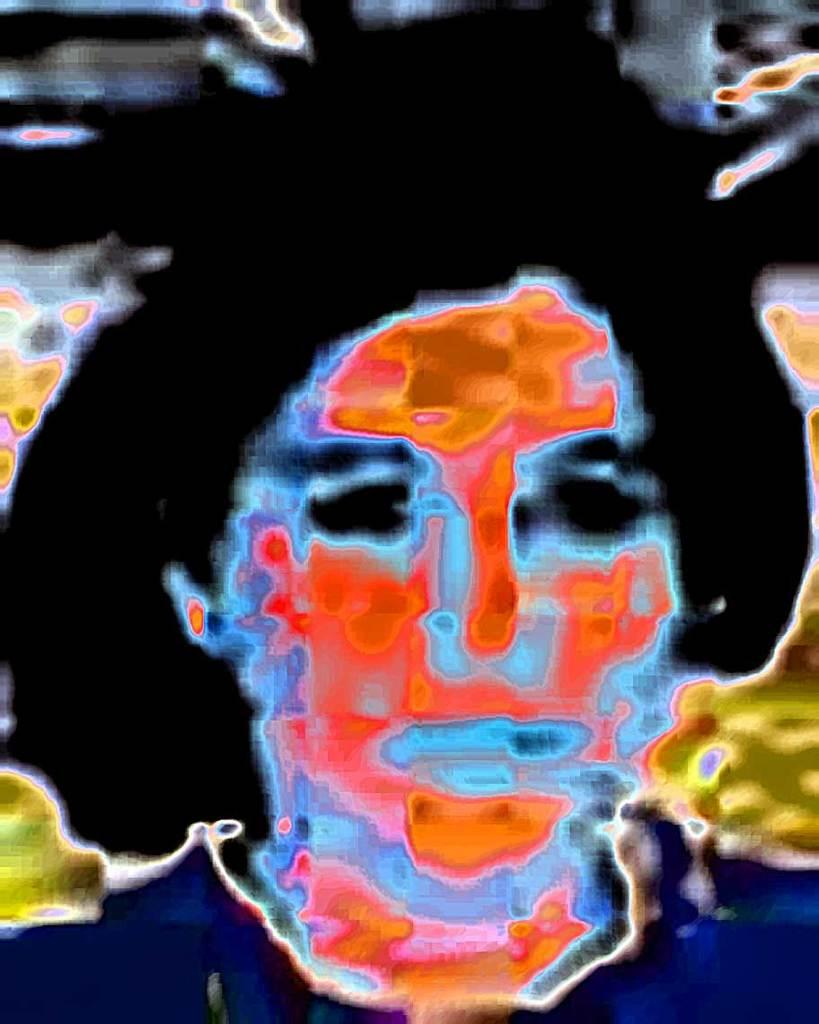How was the image altered or modified? The image is edited, which means it has been altered or modified in some way. Can you describe the person in the image? Unfortunately, the facts provided do not give any details about the person in the image. However, we can confirm that there is a person present in the image. What advice does the cow give to the person in the image? There is no cow present in the image, so it is not possible to answer that question. 